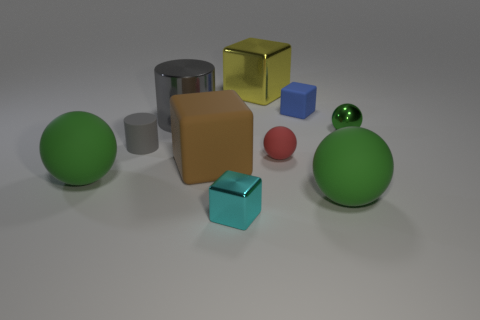Subtract all big brown rubber cubes. How many cubes are left? 3 Subtract all yellow cubes. How many cubes are left? 3 Subtract 0 purple balls. How many objects are left? 10 Subtract all cylinders. How many objects are left? 8 Subtract 2 spheres. How many spheres are left? 2 Subtract all blue cubes. Subtract all gray balls. How many cubes are left? 3 Subtract all green cylinders. How many brown cubes are left? 1 Subtract all red matte balls. Subtract all small cylinders. How many objects are left? 8 Add 5 green rubber objects. How many green rubber objects are left? 7 Add 5 large red shiny cylinders. How many large red shiny cylinders exist? 5 